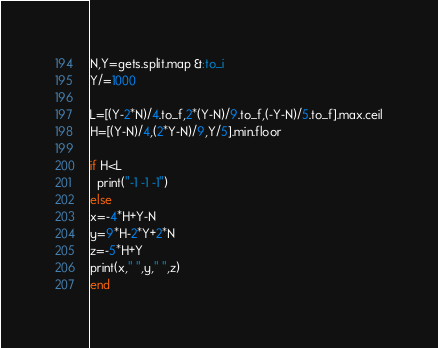<code> <loc_0><loc_0><loc_500><loc_500><_Ruby_>N,Y=gets.split.map &:to_i
Y/=1000

L=[(Y-2*N)/4.to_f,2*(Y-N)/9.to_f,(-Y-N)/5.to_f].max.ceil
H=[(Y-N)/4,(2*Y-N)/9,Y/5].min.floor

if H<L
  print("-1 -1 -1")
else
x=-4*H+Y-N
y=9*H-2*Y+2*N
z=-5*H+Y
print(x," ",y," ",z)
end</code> 